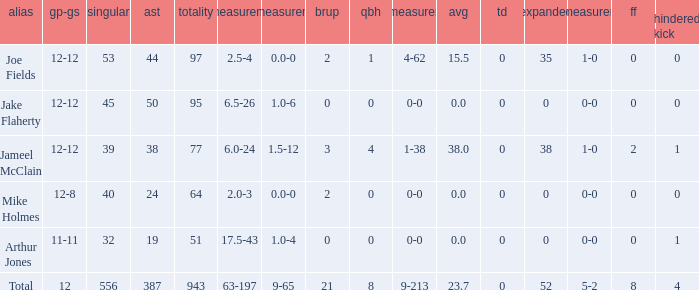How many players named jake flaherty? 1.0. 